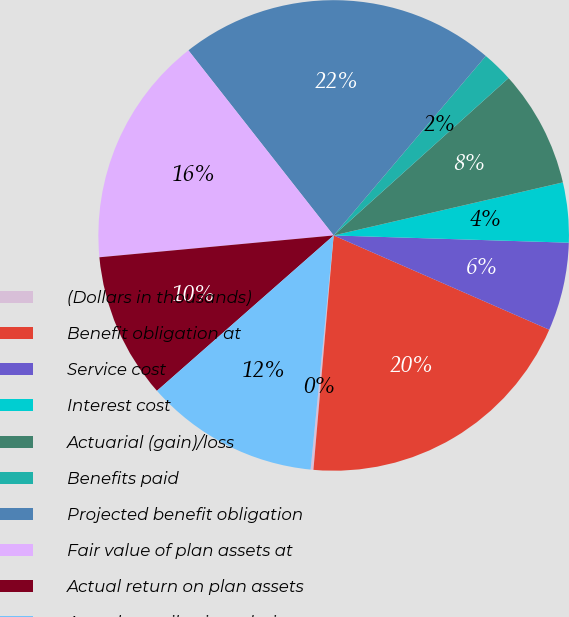<chart> <loc_0><loc_0><loc_500><loc_500><pie_chart><fcel>(Dollars in thousands)<fcel>Benefit obligation at<fcel>Service cost<fcel>Interest cost<fcel>Actuarial (gain)/loss<fcel>Benefits paid<fcel>Projected benefit obligation<fcel>Fair value of plan assets at<fcel>Actual return on plan assets<fcel>Actual contributions during<nl><fcel>0.19%<fcel>19.81%<fcel>6.07%<fcel>4.11%<fcel>8.04%<fcel>2.15%<fcel>21.78%<fcel>15.89%<fcel>10.0%<fcel>11.96%<nl></chart> 